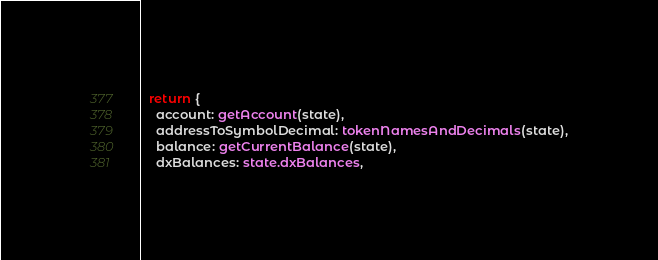Convert code to text. <code><loc_0><loc_0><loc_500><loc_500><_TypeScript_>  return {
    account: getAccount(state),
    addressToSymbolDecimal: tokenNamesAndDecimals(state),
    balance: getCurrentBalance(state),
    dxBalances: state.dxBalances,</code> 